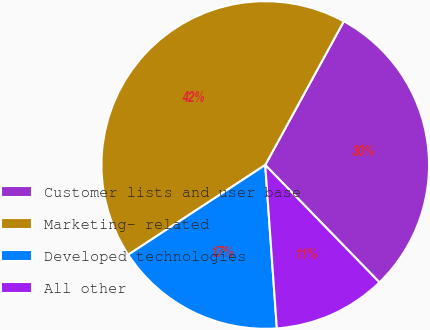Convert chart to OTSL. <chart><loc_0><loc_0><loc_500><loc_500><pie_chart><fcel>Customer lists and user base<fcel>Marketing- related<fcel>Developed technologies<fcel>All other<nl><fcel>29.76%<fcel>42.19%<fcel>16.9%<fcel>11.15%<nl></chart> 